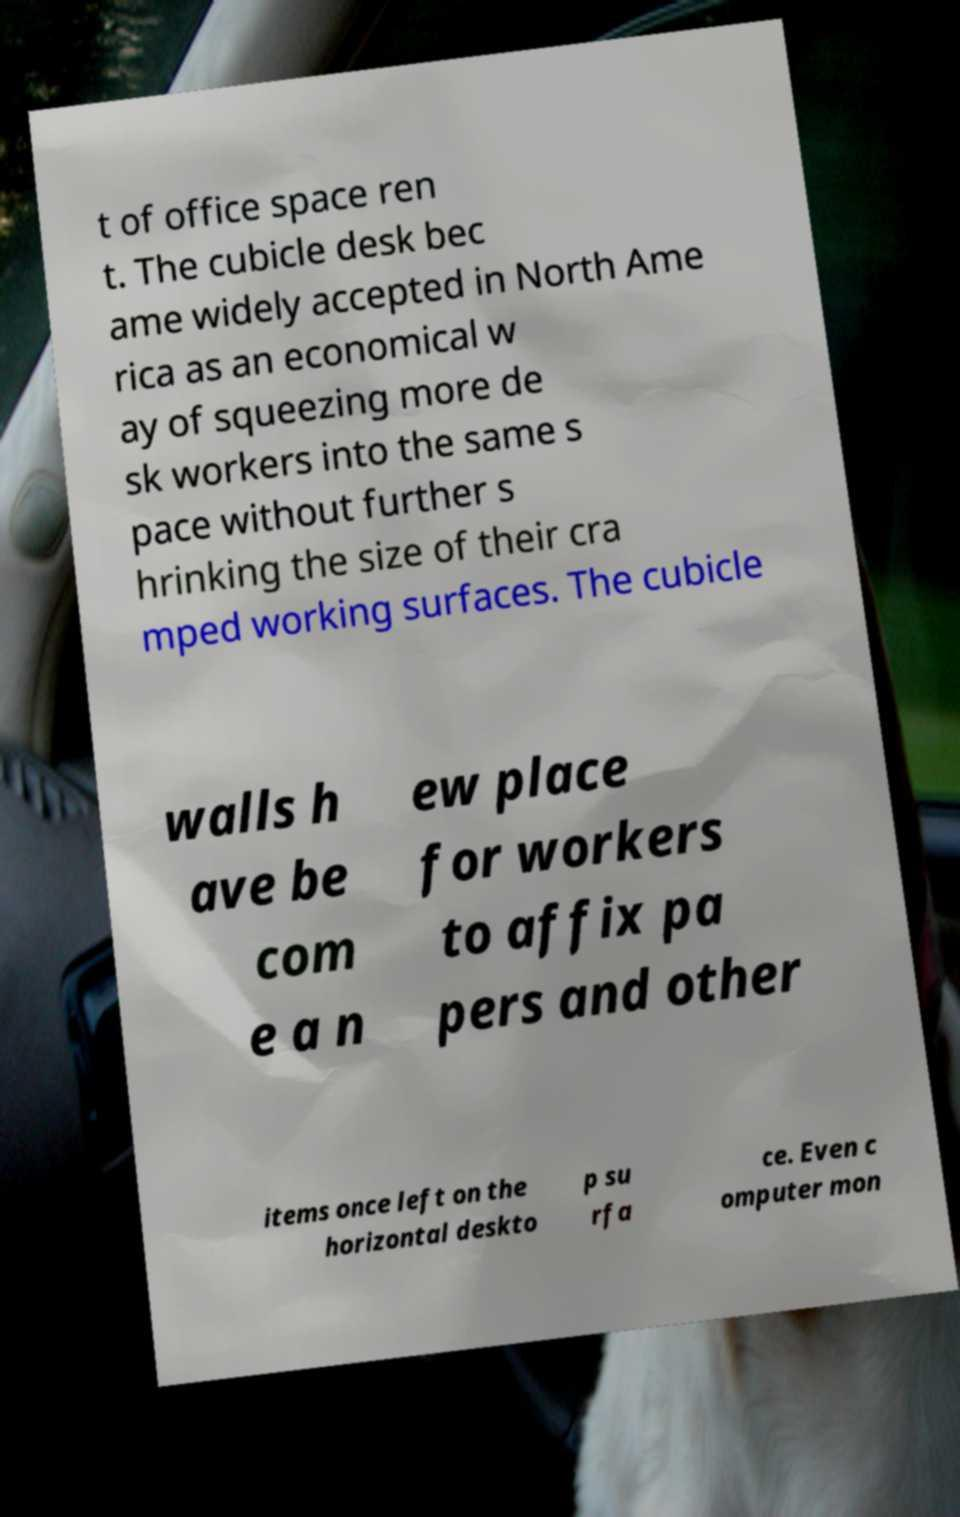Can you accurately transcribe the text from the provided image for me? t of office space ren t. The cubicle desk bec ame widely accepted in North Ame rica as an economical w ay of squeezing more de sk workers into the same s pace without further s hrinking the size of their cra mped working surfaces. The cubicle walls h ave be com e a n ew place for workers to affix pa pers and other items once left on the horizontal deskto p su rfa ce. Even c omputer mon 